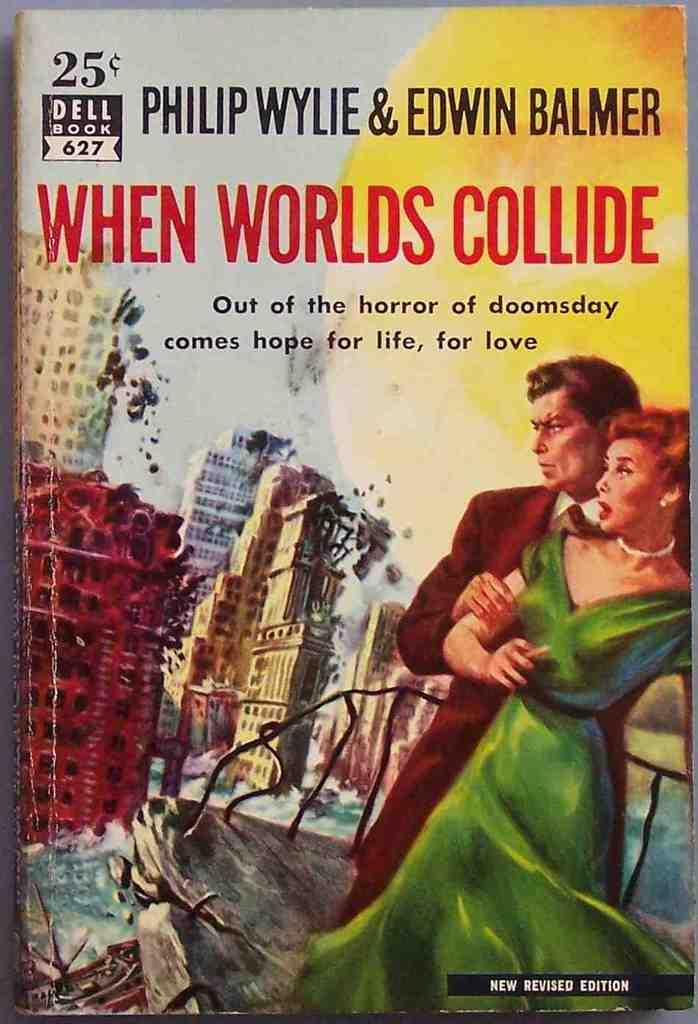<image>
Share a concise interpretation of the image provided. The book When Worlds Collide only cost 25 cents when it came out. 